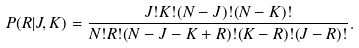Convert formula to latex. <formula><loc_0><loc_0><loc_500><loc_500>P ( R | J , K ) = \frac { J ! K ! ( N - J ) ! ( N - K ) ! } { N ! R ! ( N - J - K + R ) ! ( K - R ) ! ( J - R ) ! } .</formula> 